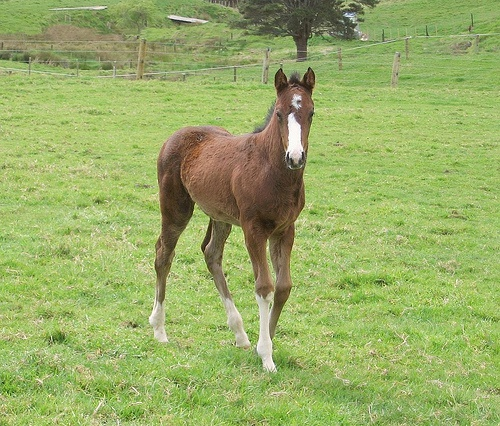Describe the objects in this image and their specific colors. I can see a horse in olive, gray, and black tones in this image. 